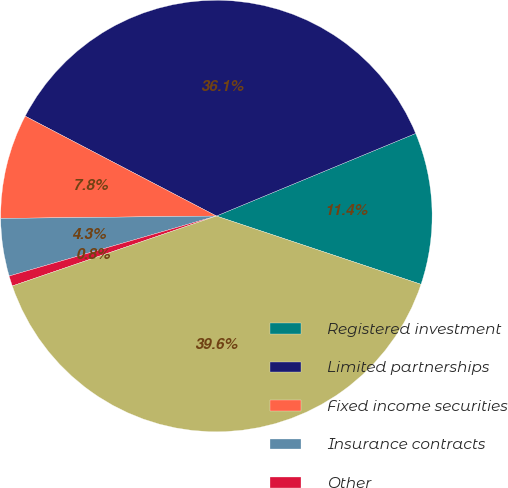<chart> <loc_0><loc_0><loc_500><loc_500><pie_chart><fcel>Registered investment<fcel>Limited partnerships<fcel>Fixed income securities<fcel>Insurance contracts<fcel>Other<fcel>Total plan assets subject to<nl><fcel>11.38%<fcel>36.09%<fcel>7.84%<fcel>4.31%<fcel>0.77%<fcel>39.62%<nl></chart> 